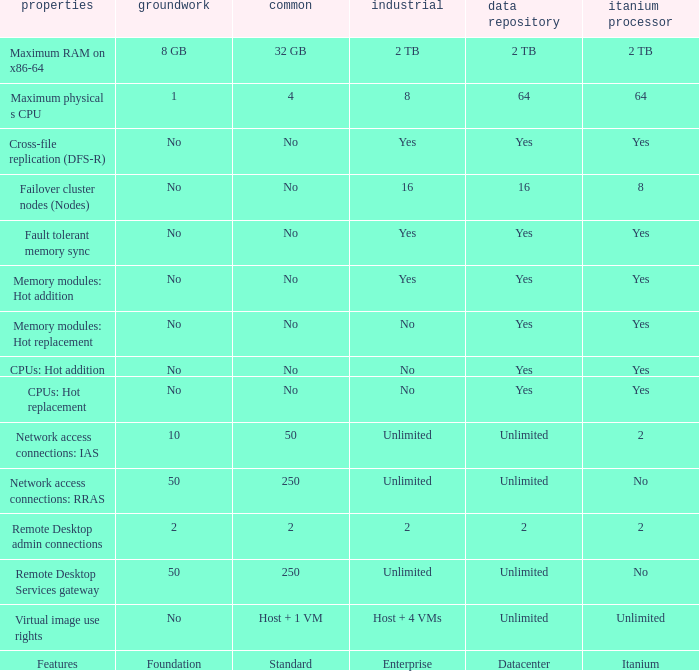Parse the full table. {'header': ['properties', 'groundwork', 'common', 'industrial', 'data repository', 'itanium processor'], 'rows': [['Maximum RAM on x86-64', '8 GB', '32 GB', '2 TB', '2 TB', '2 TB'], ['Maximum physical s CPU', '1', '4', '8', '64', '64'], ['Cross-file replication (DFS-R)', 'No', 'No', 'Yes', 'Yes', 'Yes'], ['Failover cluster nodes (Nodes)', 'No', 'No', '16', '16', '8'], ['Fault tolerant memory sync', 'No', 'No', 'Yes', 'Yes', 'Yes'], ['Memory modules: Hot addition', 'No', 'No', 'Yes', 'Yes', 'Yes'], ['Memory modules: Hot replacement', 'No', 'No', 'No', 'Yes', 'Yes'], ['CPUs: Hot addition', 'No', 'No', 'No', 'Yes', 'Yes'], ['CPUs: Hot replacement', 'No', 'No', 'No', 'Yes', 'Yes'], ['Network access connections: IAS', '10', '50', 'Unlimited', 'Unlimited', '2'], ['Network access connections: RRAS', '50', '250', 'Unlimited', 'Unlimited', 'No'], ['Remote Desktop admin connections', '2', '2', '2', '2', '2'], ['Remote Desktop Services gateway', '50', '250', 'Unlimited', 'Unlimited', 'No'], ['Virtual image use rights', 'No', 'Host + 1 VM', 'Host + 4 VMs', 'Unlimited', 'Unlimited'], ['Features', 'Foundation', 'Standard', 'Enterprise', 'Datacenter', 'Itanium']]} What is the Datacenter for the Memory modules: hot addition Feature that has Yes listed for Itanium? Yes. 